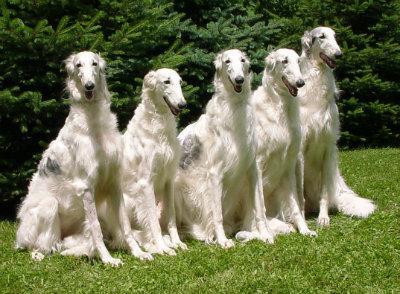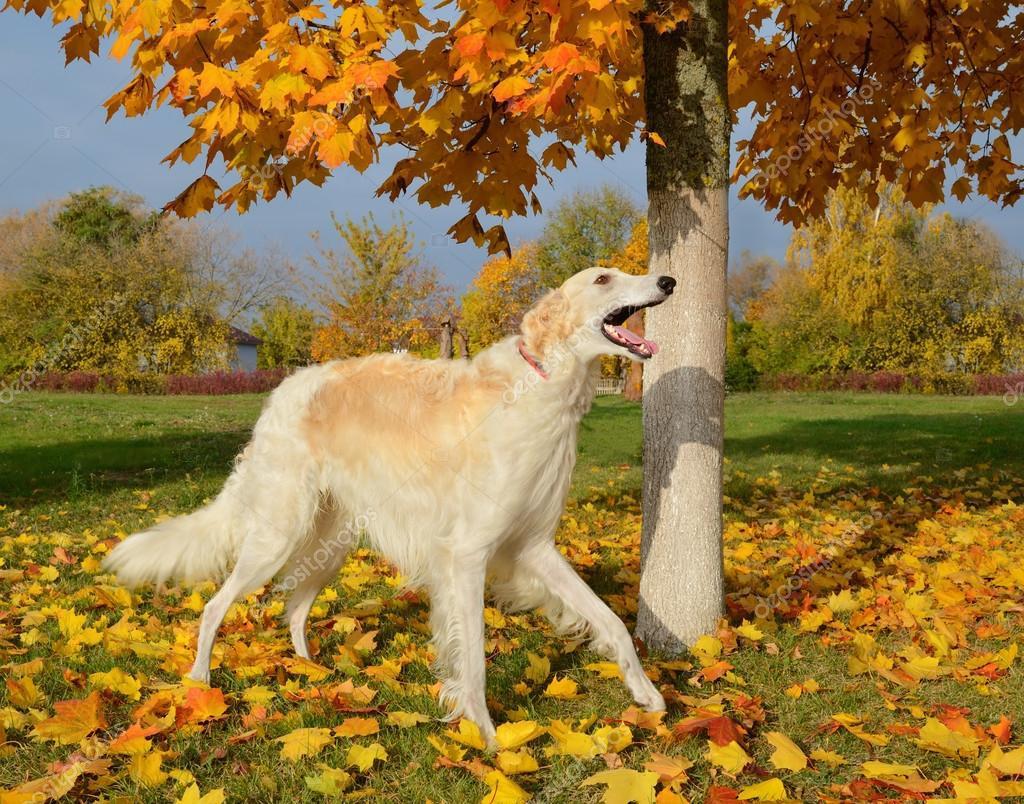The first image is the image on the left, the second image is the image on the right. For the images shown, is this caption "The left image contains at least three times as many hounds as the right image." true? Answer yes or no. Yes. The first image is the image on the left, the second image is the image on the right. Analyze the images presented: Is the assertion "The single white dog in the image on the left is standing in a grassy area." valid? Answer yes or no. No. 